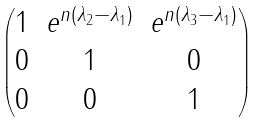Convert formula to latex. <formula><loc_0><loc_0><loc_500><loc_500>\begin{pmatrix} 1 & e ^ { n ( \lambda _ { 2 } - \lambda _ { 1 } ) } & e ^ { n ( \lambda _ { 3 } - \lambda _ { 1 } ) } \\ 0 & 1 & 0 \\ 0 & 0 & 1 \end{pmatrix}</formula> 